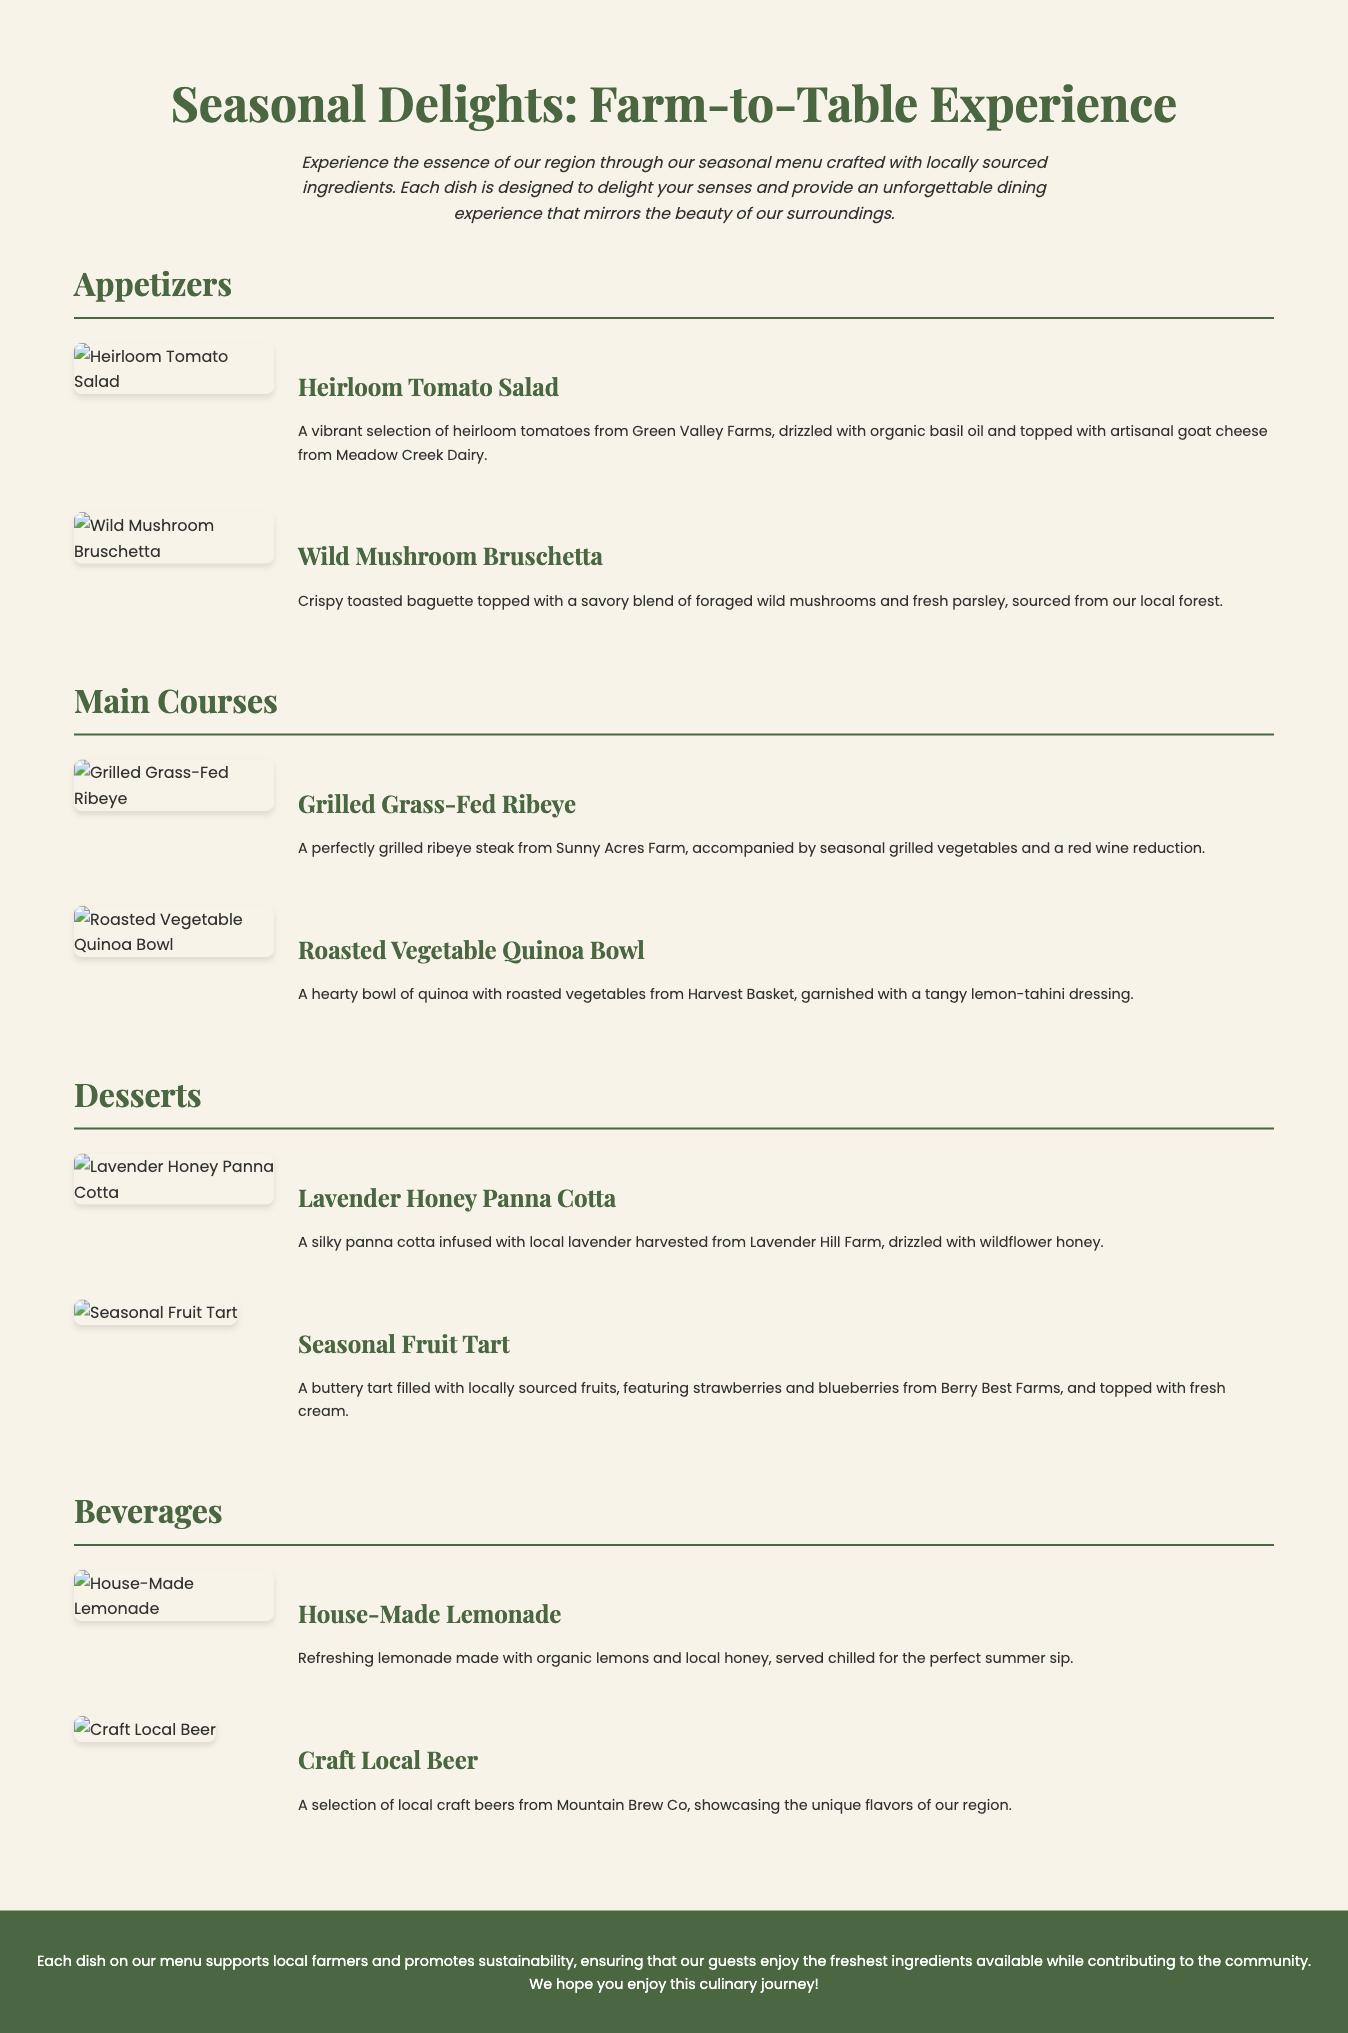What is the title of the menu? The title is prominently displayed at the top of the document, reading "Seasonal Delights: Farm-to-Table Experience."
Answer: Seasonal Delights: Farm-to-Table Experience What type of salad is featured in the appetizers? The document lists "Heirloom Tomato Salad" as one of the appetizers.
Answer: Heirloom Tomato Salad Which farm provides the ribeye steak? The grilled ribeye steak is sourced from a specific farm, which is stated as "Sunny Acres Farm."
Answer: Sunny Acres Farm What is the main ingredient in the Lavender Honey Panna Cotta? The description of the dessert highlights local lavender as a key ingredient in the panna cotta.
Answer: Lavender What is the main vegetarian option in the main courses? The menu shows "Roasted Vegetable Quinoa Bowl" as a hearty vegetarian dish.
Answer: Roasted Vegetable Quinoa Bowl How many beverage options are listed in the menu? The menu presents two beverage options under the beverages section.
Answer: Two What type of cheese is on the Heirloom Tomato Salad? The salad is topped with "artisanal goat cheese" from a local dairy.
Answer: Artisanal goat cheese What feature tops the Seasonal Fruit Tart? The tart is adorned with a specific component mentioned in the description: "fresh cream."
Answer: Fresh cream What is a key value promoted by the menu's offerings? The footer states a strong commitment to supporting local farmers and sustainability as a core value.
Answer: Sustainability 